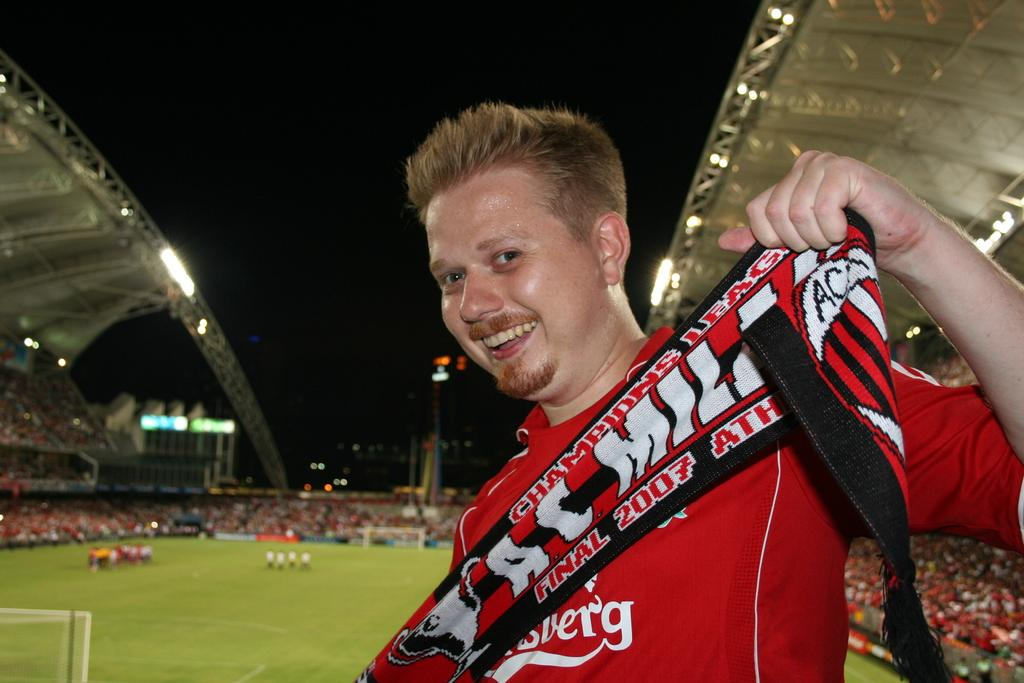<image>
Render a clear and concise summary of the photo. A fan brandishes a red and black scarf for the AC Milan team 